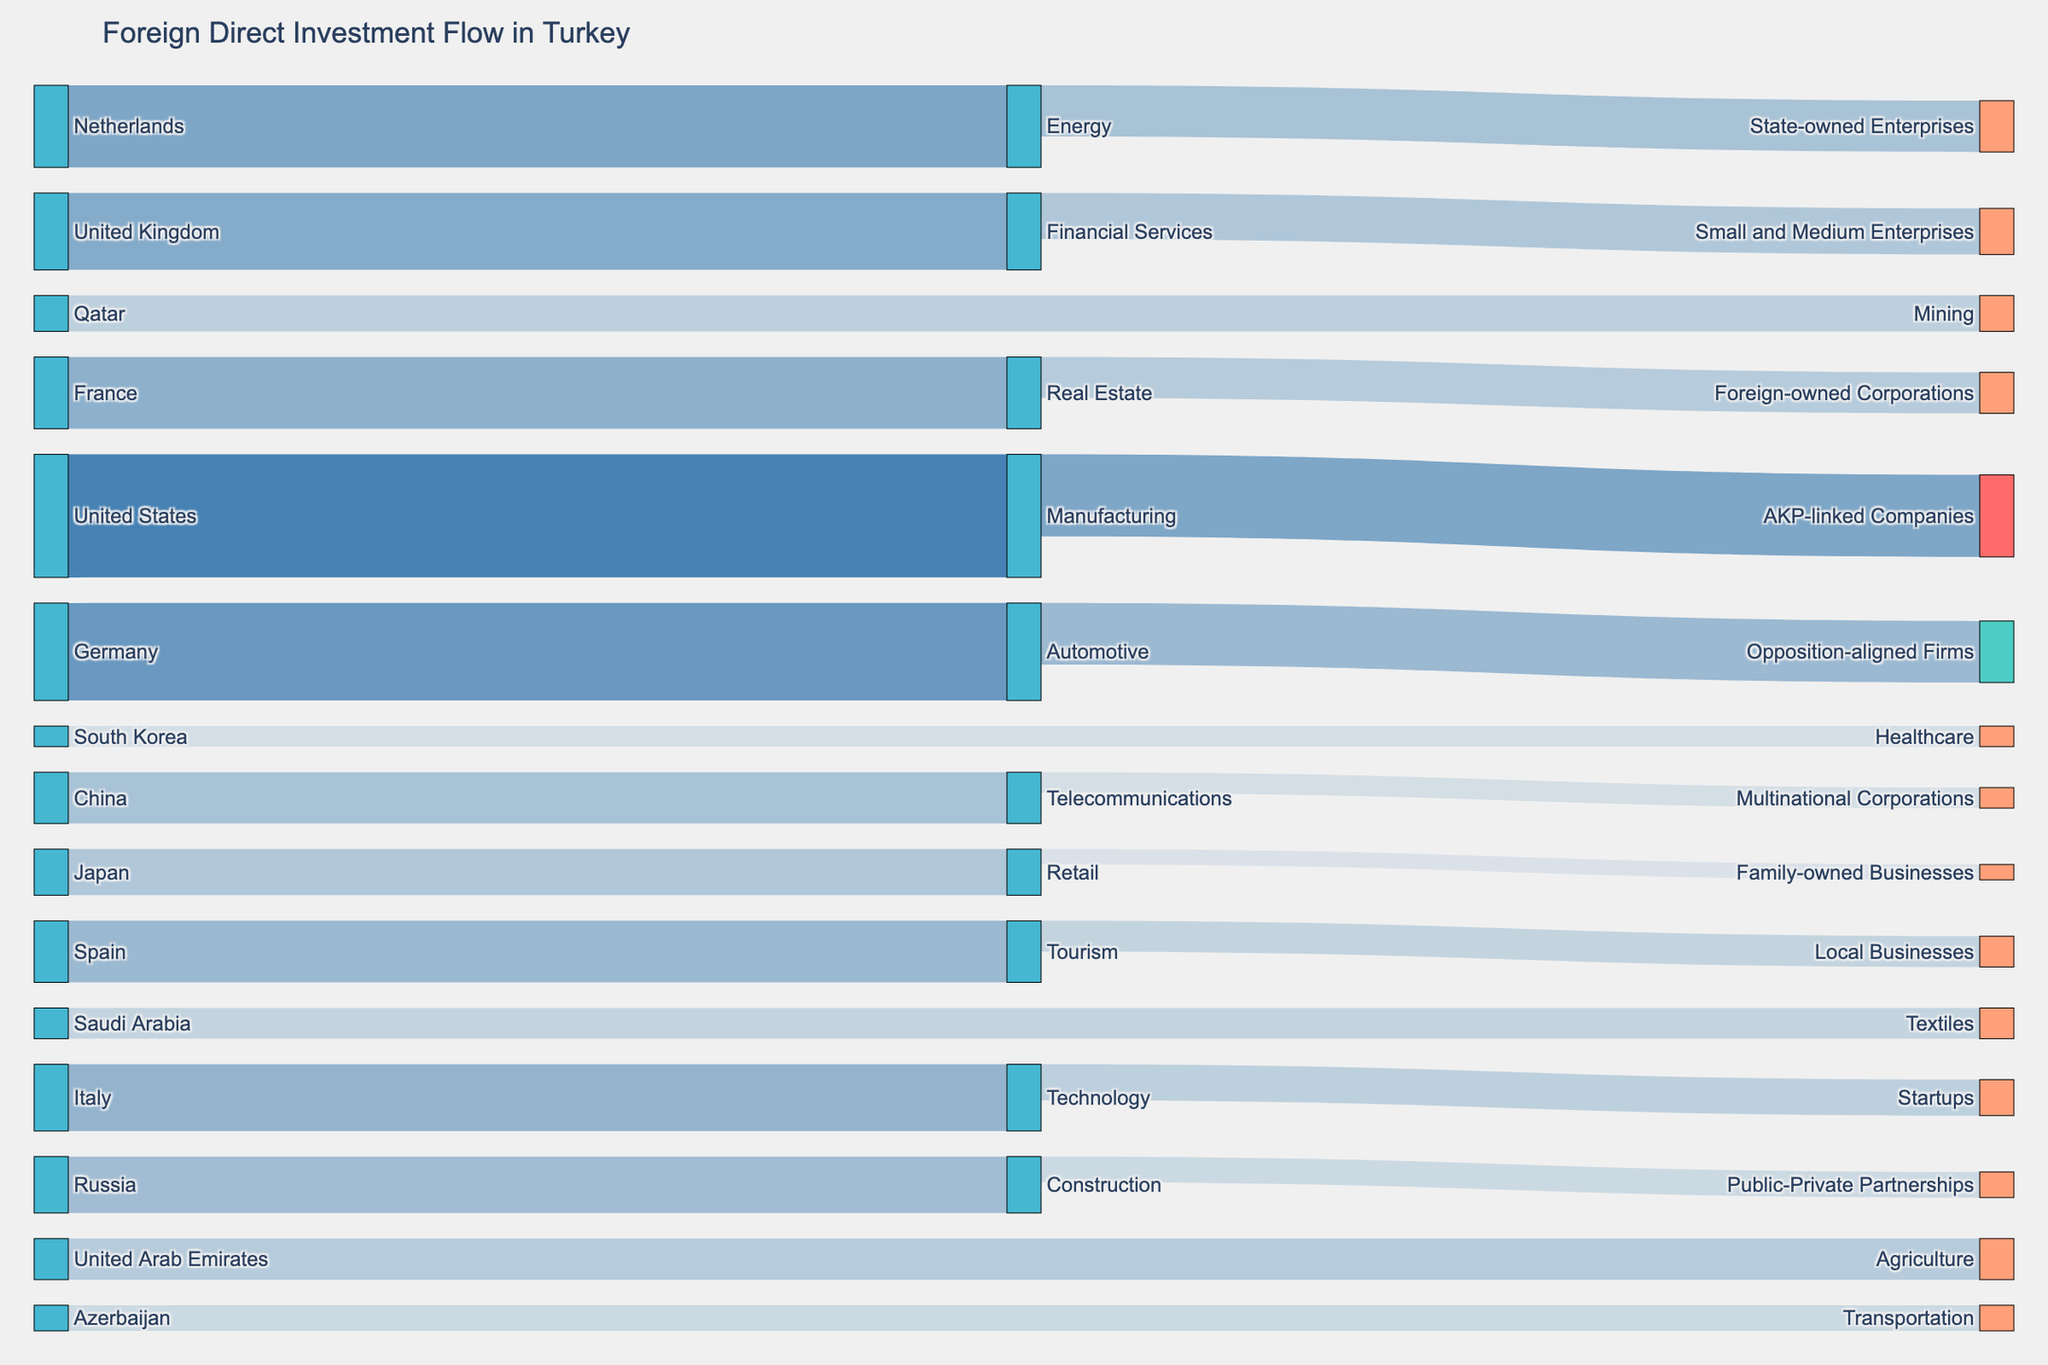What is the title of the figure? The title can be found at the top of the figure.
Answer: Foreign Direct Investment Flow in Turkey Which country made the largest investment in the manufacturing sector? Examine the 'source' and 'target' nodes connected to the manufacturing sector and identify which one has the highest value.
Answer: United States How much did Germany invest in the automotive sector? Find the flow from Germany to the automotive sector and read the value.
Answer: 950 Which sector received the highest total investment from all listed countries? Summing up the values of incoming investments for each sector: Manufacturing (1200), Automotive (950), Energy (800), Financial Services (750), Real Estate (700), Technology (650), Tourism (600), Construction (550), Telecommunications (500), Retail (450), Agriculture (400), Mining (350), Textiles (300), Transportation (250), Healthcare (200). The highest sum identifies the sector.
Answer: Manufacturing Which countries invested in the AKP-linked Companies? Identify the target node labeled "AKP-linked Companies" and trace back to the source nodes.
Answer: United States How much more did the United States invest in the manufacturing sector than Italy invested in technology? Find the values for each investment and subtract Italy's investment from the United States' investment. (1200 - 650 = 550)
Answer: 550 Does the tourism sector receive more or less investment than the technology sector? Compare the values of investments in the tourism sector and the technology sector.
Answer: Less Which sector attracted the smallest investment and from which country? Looking at the least values and identifying the corresponding country and sector combination.
Answer: Healthcare from South Korea How does the investment in the automotive sector by Germany compare to the investment in financial services by the United Kingdom? Identify the values for both investments and compare them. (950 vs. 750)
Answer: More Which type of companies received investment from the telecommunications sector? Identify the 'target' node connected to the telecommunications sector and read the label.
Answer: Multinational Corporations 